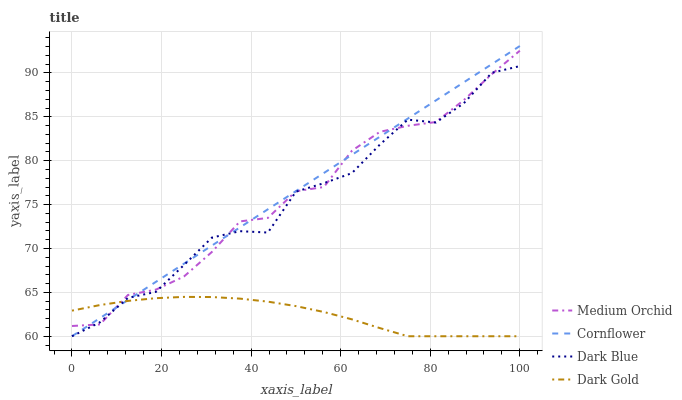Does Dark Gold have the minimum area under the curve?
Answer yes or no. Yes. Does Cornflower have the maximum area under the curve?
Answer yes or no. Yes. Does Medium Orchid have the minimum area under the curve?
Answer yes or no. No. Does Medium Orchid have the maximum area under the curve?
Answer yes or no. No. Is Cornflower the smoothest?
Answer yes or no. Yes. Is Dark Blue the roughest?
Answer yes or no. Yes. Is Medium Orchid the smoothest?
Answer yes or no. No. Is Medium Orchid the roughest?
Answer yes or no. No. Does Cornflower have the lowest value?
Answer yes or no. Yes. Does Medium Orchid have the lowest value?
Answer yes or no. No. Does Cornflower have the highest value?
Answer yes or no. Yes. Does Medium Orchid have the highest value?
Answer yes or no. No. Does Dark Blue intersect Medium Orchid?
Answer yes or no. Yes. Is Dark Blue less than Medium Orchid?
Answer yes or no. No. Is Dark Blue greater than Medium Orchid?
Answer yes or no. No. 